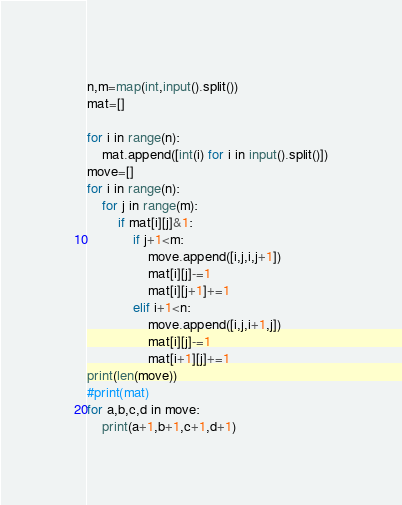Convert code to text. <code><loc_0><loc_0><loc_500><loc_500><_Python_>n,m=map(int,input().split())
mat=[]

for i in range(n):
    mat.append([int(i) for i in input().split()])
move=[]
for i in range(n):
    for j in range(m):
        if mat[i][j]&1: 
            if j+1<m: 
                move.append([i,j,i,j+1])
                mat[i][j]-=1 
                mat[i][j+1]+=1 
            elif i+1<n:
                move.append([i,j,i+1,j])
                mat[i][j]-=1 
                mat[i+1][j]+=1 
print(len(move))
#print(mat)
for a,b,c,d in move:
    print(a+1,b+1,c+1,d+1)</code> 